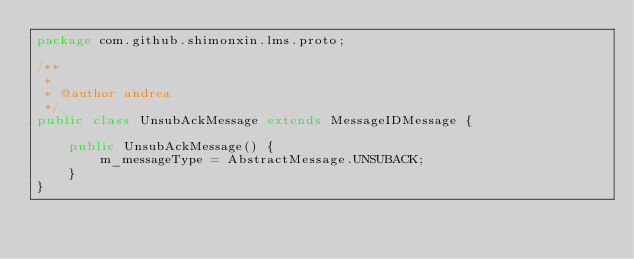<code> <loc_0><loc_0><loc_500><loc_500><_Java_>package com.github.shimonxin.lms.proto;

/**
 *
 * @author andrea
 */
public class UnsubAckMessage extends MessageIDMessage {
    
    public UnsubAckMessage() {
        m_messageType = AbstractMessage.UNSUBACK;
    }
}

</code> 